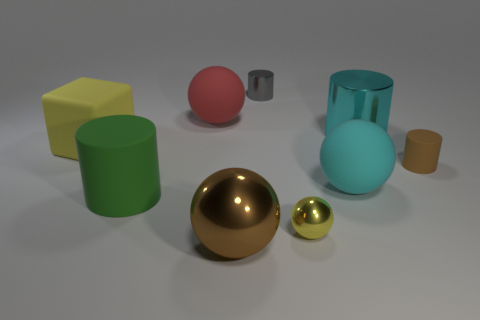Subtract all small yellow spheres. How many spheres are left? 3 Subtract all brown cylinders. How many cylinders are left? 3 Subtract 2 balls. How many balls are left? 2 Add 1 small shiny spheres. How many objects exist? 10 Subtract all cubes. How many objects are left? 8 Subtract all red cylinders. Subtract all yellow blocks. How many cylinders are left? 4 Add 2 gray metal cubes. How many gray metal cubes exist? 2 Subtract 0 green spheres. How many objects are left? 9 Subtract all big cyan shiny objects. Subtract all tiny green rubber objects. How many objects are left? 8 Add 4 yellow matte cubes. How many yellow matte cubes are left? 5 